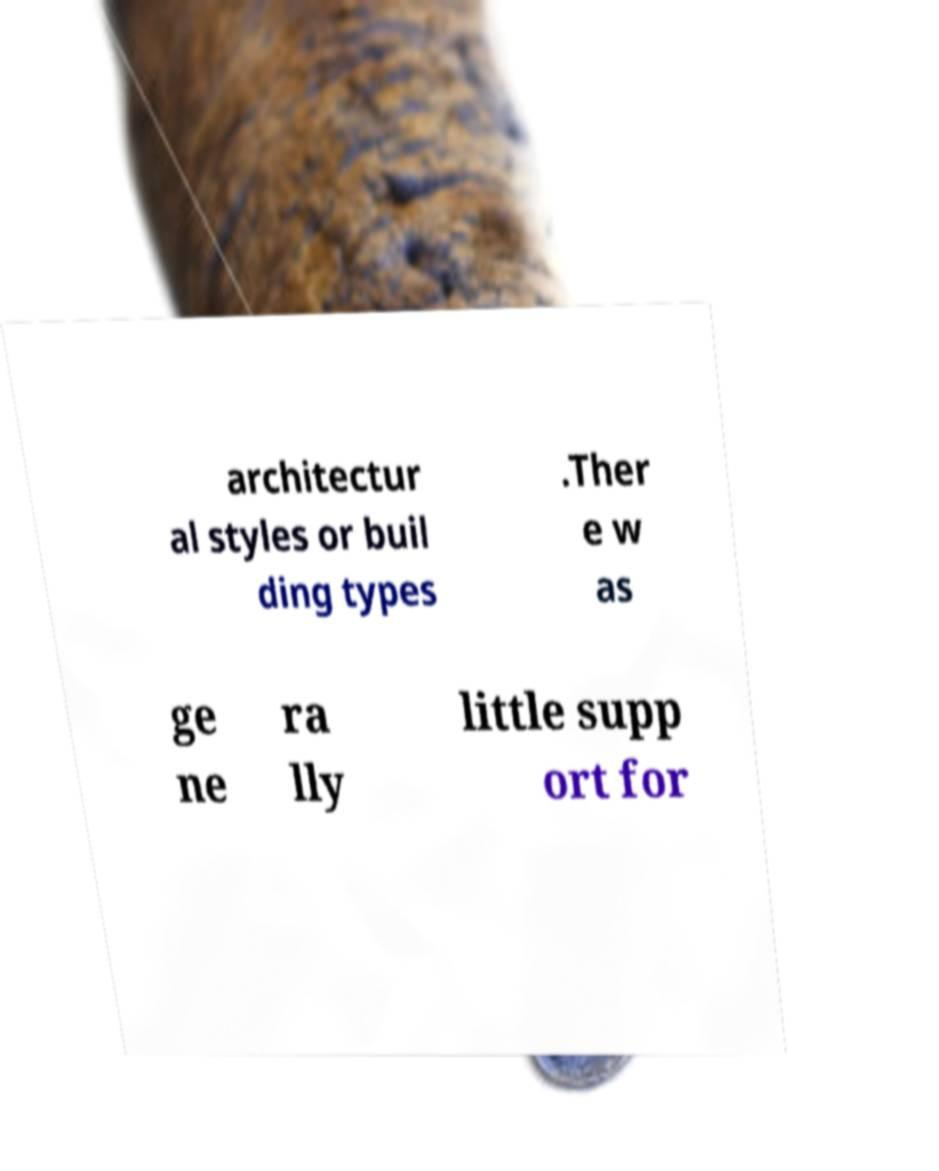Please identify and transcribe the text found in this image. architectur al styles or buil ding types .Ther e w as ge ne ra lly little supp ort for 